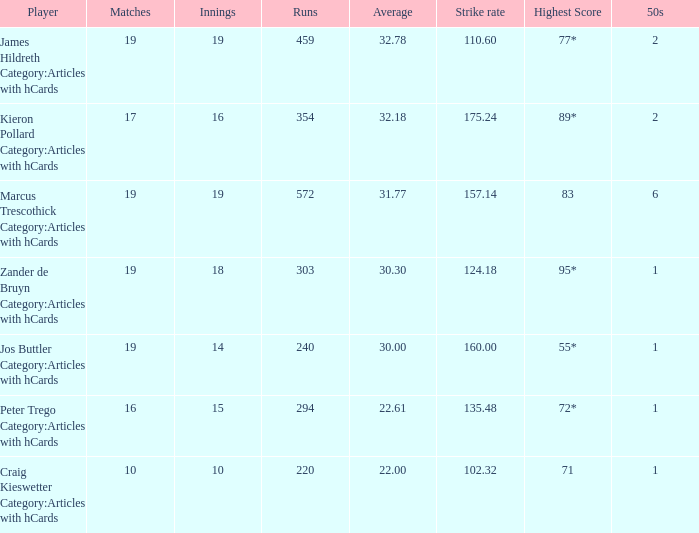What is the number of innings for a player with a 2 15.0. Write the full table. {'header': ['Player', 'Matches', 'Innings', 'Runs', 'Average', 'Strike rate', 'Highest Score', '50s'], 'rows': [['James Hildreth Category:Articles with hCards', '19', '19', '459', '32.78', '110.60', '77*', '2'], ['Kieron Pollard Category:Articles with hCards', '17', '16', '354', '32.18', '175.24', '89*', '2'], ['Marcus Trescothick Category:Articles with hCards', '19', '19', '572', '31.77', '157.14', '83', '6'], ['Zander de Bruyn Category:Articles with hCards', '19', '18', '303', '30.30', '124.18', '95*', '1'], ['Jos Buttler Category:Articles with hCards', '19', '14', '240', '30.00', '160.00', '55*', '1'], ['Peter Trego Category:Articles with hCards', '16', '15', '294', '22.61', '135.48', '72*', '1'], ['Craig Kieswetter Category:Articles with hCards', '10', '10', '220', '22.00', '102.32', '71', '1']]} 